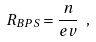<formula> <loc_0><loc_0><loc_500><loc_500>R _ { B P S } = \frac { n } { e v } \ ,</formula> 